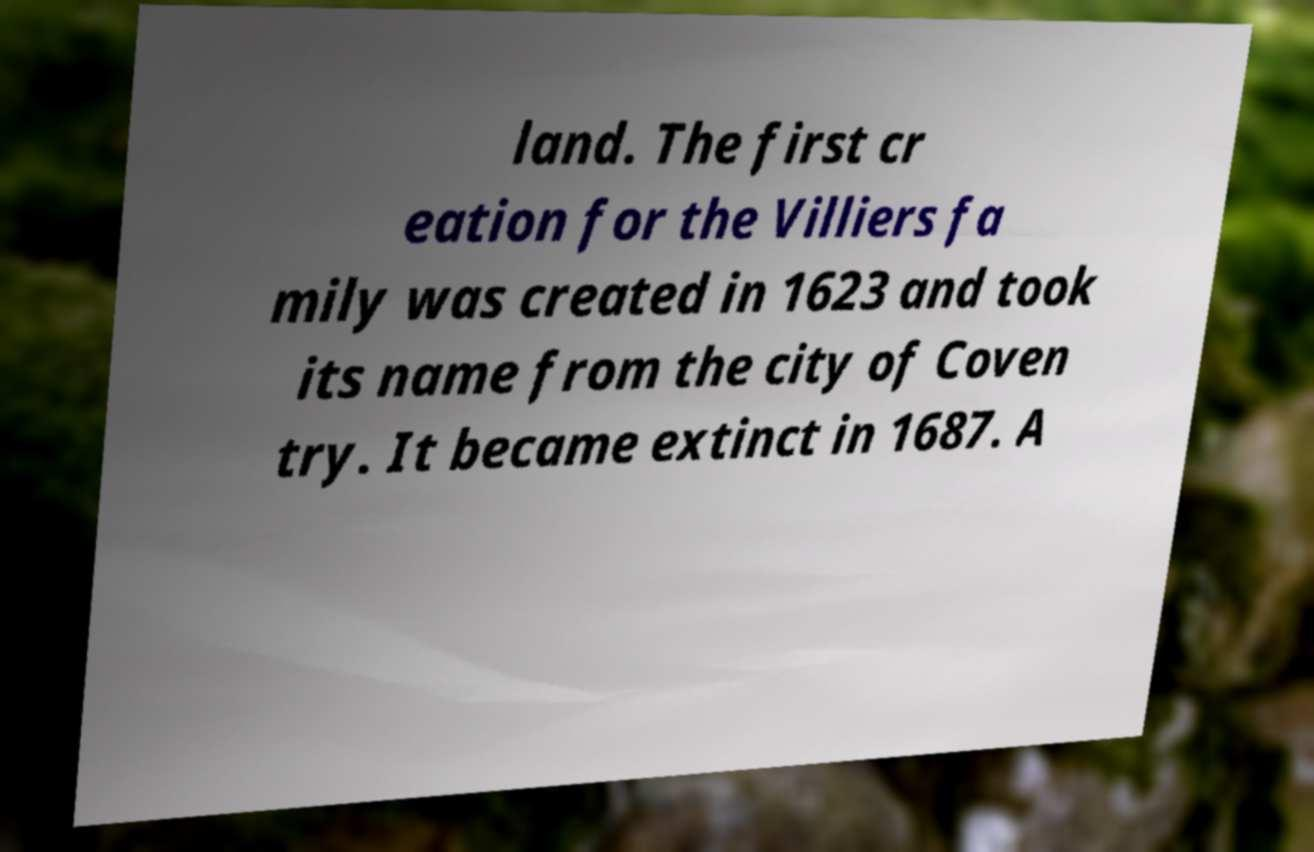I need the written content from this picture converted into text. Can you do that? land. The first cr eation for the Villiers fa mily was created in 1623 and took its name from the city of Coven try. It became extinct in 1687. A 